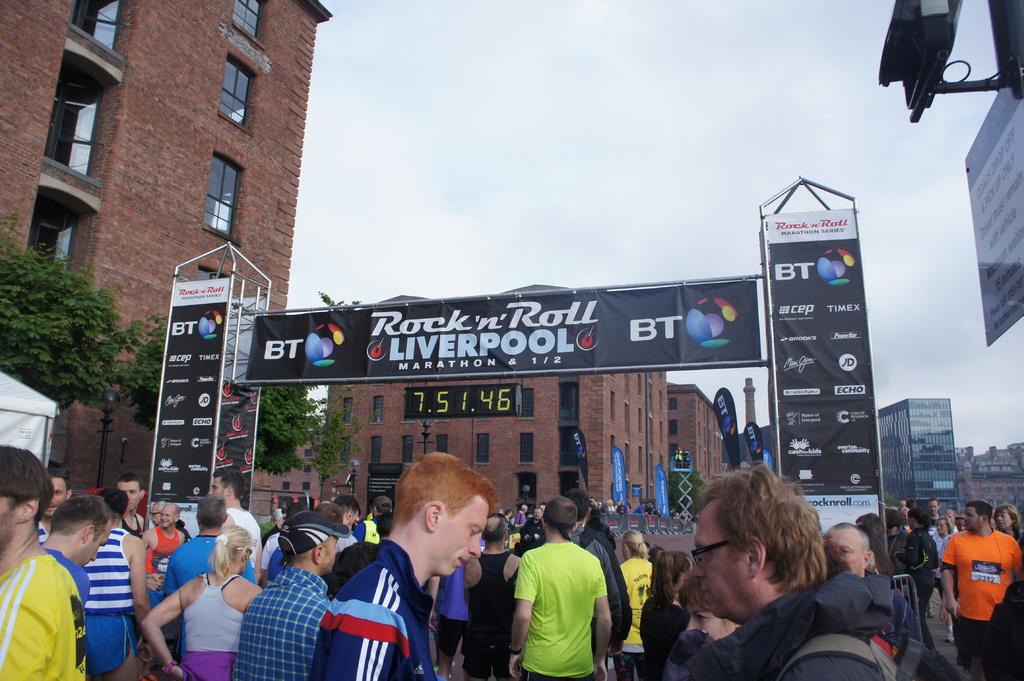What time is on the clock?
Your response must be concise. 7.51.46. 